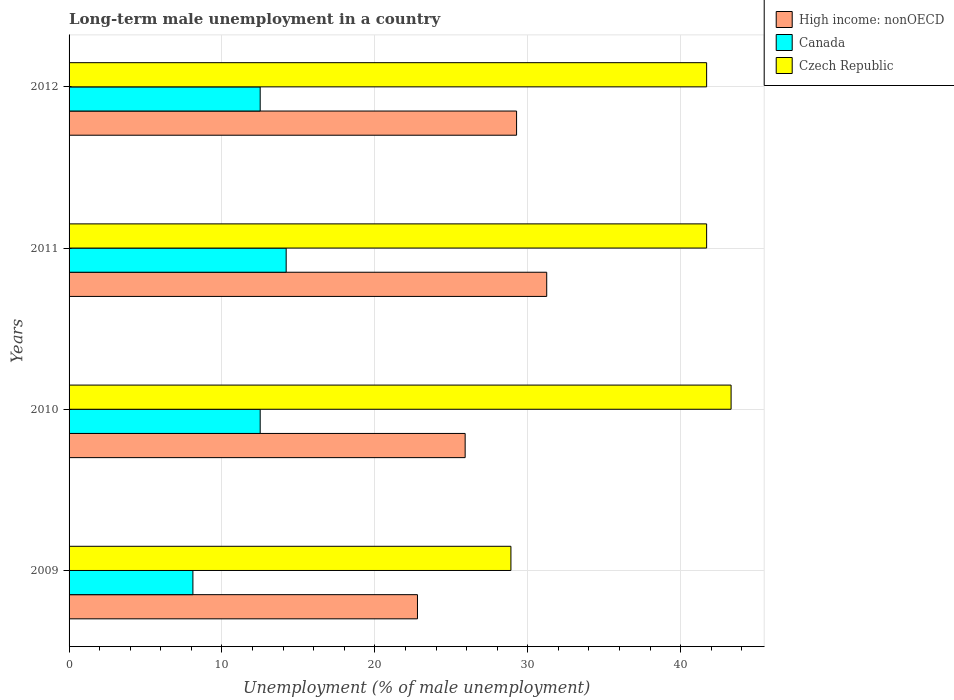How many different coloured bars are there?
Your answer should be very brief. 3. How many groups of bars are there?
Offer a terse response. 4. Are the number of bars on each tick of the Y-axis equal?
Your answer should be compact. Yes. How many bars are there on the 2nd tick from the top?
Your answer should be compact. 3. How many bars are there on the 1st tick from the bottom?
Give a very brief answer. 3. What is the label of the 3rd group of bars from the top?
Keep it short and to the point. 2010. What is the percentage of long-term unemployed male population in Czech Republic in 2009?
Your answer should be compact. 28.9. Across all years, what is the maximum percentage of long-term unemployed male population in High income: nonOECD?
Provide a short and direct response. 31.24. Across all years, what is the minimum percentage of long-term unemployed male population in Czech Republic?
Keep it short and to the point. 28.9. In which year was the percentage of long-term unemployed male population in Czech Republic maximum?
Give a very brief answer. 2010. In which year was the percentage of long-term unemployed male population in High income: nonOECD minimum?
Give a very brief answer. 2009. What is the total percentage of long-term unemployed male population in Czech Republic in the graph?
Make the answer very short. 155.6. What is the difference between the percentage of long-term unemployed male population in Canada in 2010 and that in 2012?
Offer a terse response. 0. What is the difference between the percentage of long-term unemployed male population in Canada in 2009 and the percentage of long-term unemployed male population in Czech Republic in 2011?
Offer a very short reply. -33.6. What is the average percentage of long-term unemployed male population in High income: nonOECD per year?
Offer a terse response. 27.3. In the year 2011, what is the difference between the percentage of long-term unemployed male population in High income: nonOECD and percentage of long-term unemployed male population in Canada?
Ensure brevity in your answer.  17.04. What is the ratio of the percentage of long-term unemployed male population in Canada in 2009 to that in 2012?
Make the answer very short. 0.65. What is the difference between the highest and the second highest percentage of long-term unemployed male population in High income: nonOECD?
Your answer should be very brief. 1.97. What is the difference between the highest and the lowest percentage of long-term unemployed male population in Czech Republic?
Your answer should be compact. 14.4. In how many years, is the percentage of long-term unemployed male population in High income: nonOECD greater than the average percentage of long-term unemployed male population in High income: nonOECD taken over all years?
Keep it short and to the point. 2. What does the 1st bar from the top in 2009 represents?
Provide a succinct answer. Czech Republic. What does the 3rd bar from the bottom in 2012 represents?
Make the answer very short. Czech Republic. Are all the bars in the graph horizontal?
Ensure brevity in your answer.  Yes. How many years are there in the graph?
Provide a succinct answer. 4. Does the graph contain any zero values?
Your response must be concise. No. Does the graph contain grids?
Your response must be concise. Yes. What is the title of the graph?
Provide a short and direct response. Long-term male unemployment in a country. Does "Mozambique" appear as one of the legend labels in the graph?
Your answer should be very brief. No. What is the label or title of the X-axis?
Provide a short and direct response. Unemployment (% of male unemployment). What is the label or title of the Y-axis?
Your answer should be very brief. Years. What is the Unemployment (% of male unemployment) in High income: nonOECD in 2009?
Provide a succinct answer. 22.79. What is the Unemployment (% of male unemployment) of Canada in 2009?
Make the answer very short. 8.1. What is the Unemployment (% of male unemployment) in Czech Republic in 2009?
Make the answer very short. 28.9. What is the Unemployment (% of male unemployment) in High income: nonOECD in 2010?
Your answer should be very brief. 25.91. What is the Unemployment (% of male unemployment) of Canada in 2010?
Provide a short and direct response. 12.5. What is the Unemployment (% of male unemployment) of Czech Republic in 2010?
Ensure brevity in your answer.  43.3. What is the Unemployment (% of male unemployment) in High income: nonOECD in 2011?
Offer a terse response. 31.24. What is the Unemployment (% of male unemployment) in Canada in 2011?
Your response must be concise. 14.2. What is the Unemployment (% of male unemployment) in Czech Republic in 2011?
Provide a succinct answer. 41.7. What is the Unemployment (% of male unemployment) in High income: nonOECD in 2012?
Give a very brief answer. 29.27. What is the Unemployment (% of male unemployment) of Canada in 2012?
Give a very brief answer. 12.5. What is the Unemployment (% of male unemployment) of Czech Republic in 2012?
Ensure brevity in your answer.  41.7. Across all years, what is the maximum Unemployment (% of male unemployment) of High income: nonOECD?
Ensure brevity in your answer.  31.24. Across all years, what is the maximum Unemployment (% of male unemployment) of Canada?
Provide a short and direct response. 14.2. Across all years, what is the maximum Unemployment (% of male unemployment) in Czech Republic?
Keep it short and to the point. 43.3. Across all years, what is the minimum Unemployment (% of male unemployment) of High income: nonOECD?
Your answer should be very brief. 22.79. Across all years, what is the minimum Unemployment (% of male unemployment) of Canada?
Your response must be concise. 8.1. Across all years, what is the minimum Unemployment (% of male unemployment) in Czech Republic?
Your response must be concise. 28.9. What is the total Unemployment (% of male unemployment) in High income: nonOECD in the graph?
Provide a short and direct response. 109.2. What is the total Unemployment (% of male unemployment) in Canada in the graph?
Your answer should be very brief. 47.3. What is the total Unemployment (% of male unemployment) of Czech Republic in the graph?
Provide a short and direct response. 155.6. What is the difference between the Unemployment (% of male unemployment) in High income: nonOECD in 2009 and that in 2010?
Provide a succinct answer. -3.12. What is the difference between the Unemployment (% of male unemployment) of Canada in 2009 and that in 2010?
Your response must be concise. -4.4. What is the difference between the Unemployment (% of male unemployment) of Czech Republic in 2009 and that in 2010?
Your answer should be very brief. -14.4. What is the difference between the Unemployment (% of male unemployment) in High income: nonOECD in 2009 and that in 2011?
Your response must be concise. -8.45. What is the difference between the Unemployment (% of male unemployment) of Canada in 2009 and that in 2011?
Keep it short and to the point. -6.1. What is the difference between the Unemployment (% of male unemployment) of Czech Republic in 2009 and that in 2011?
Keep it short and to the point. -12.8. What is the difference between the Unemployment (% of male unemployment) in High income: nonOECD in 2009 and that in 2012?
Provide a short and direct response. -6.48. What is the difference between the Unemployment (% of male unemployment) of Canada in 2009 and that in 2012?
Ensure brevity in your answer.  -4.4. What is the difference between the Unemployment (% of male unemployment) of High income: nonOECD in 2010 and that in 2011?
Keep it short and to the point. -5.34. What is the difference between the Unemployment (% of male unemployment) of Czech Republic in 2010 and that in 2011?
Offer a terse response. 1.6. What is the difference between the Unemployment (% of male unemployment) in High income: nonOECD in 2010 and that in 2012?
Keep it short and to the point. -3.36. What is the difference between the Unemployment (% of male unemployment) of Canada in 2010 and that in 2012?
Ensure brevity in your answer.  0. What is the difference between the Unemployment (% of male unemployment) in Czech Republic in 2010 and that in 2012?
Ensure brevity in your answer.  1.6. What is the difference between the Unemployment (% of male unemployment) in High income: nonOECD in 2011 and that in 2012?
Your answer should be very brief. 1.97. What is the difference between the Unemployment (% of male unemployment) of Canada in 2011 and that in 2012?
Your answer should be compact. 1.7. What is the difference between the Unemployment (% of male unemployment) in Czech Republic in 2011 and that in 2012?
Provide a short and direct response. 0. What is the difference between the Unemployment (% of male unemployment) in High income: nonOECD in 2009 and the Unemployment (% of male unemployment) in Canada in 2010?
Your answer should be compact. 10.29. What is the difference between the Unemployment (% of male unemployment) of High income: nonOECD in 2009 and the Unemployment (% of male unemployment) of Czech Republic in 2010?
Your response must be concise. -20.51. What is the difference between the Unemployment (% of male unemployment) in Canada in 2009 and the Unemployment (% of male unemployment) in Czech Republic in 2010?
Make the answer very short. -35.2. What is the difference between the Unemployment (% of male unemployment) of High income: nonOECD in 2009 and the Unemployment (% of male unemployment) of Canada in 2011?
Your answer should be compact. 8.59. What is the difference between the Unemployment (% of male unemployment) in High income: nonOECD in 2009 and the Unemployment (% of male unemployment) in Czech Republic in 2011?
Offer a terse response. -18.91. What is the difference between the Unemployment (% of male unemployment) of Canada in 2009 and the Unemployment (% of male unemployment) of Czech Republic in 2011?
Offer a very short reply. -33.6. What is the difference between the Unemployment (% of male unemployment) of High income: nonOECD in 2009 and the Unemployment (% of male unemployment) of Canada in 2012?
Your answer should be very brief. 10.29. What is the difference between the Unemployment (% of male unemployment) of High income: nonOECD in 2009 and the Unemployment (% of male unemployment) of Czech Republic in 2012?
Provide a succinct answer. -18.91. What is the difference between the Unemployment (% of male unemployment) in Canada in 2009 and the Unemployment (% of male unemployment) in Czech Republic in 2012?
Your response must be concise. -33.6. What is the difference between the Unemployment (% of male unemployment) of High income: nonOECD in 2010 and the Unemployment (% of male unemployment) of Canada in 2011?
Provide a succinct answer. 11.71. What is the difference between the Unemployment (% of male unemployment) in High income: nonOECD in 2010 and the Unemployment (% of male unemployment) in Czech Republic in 2011?
Give a very brief answer. -15.79. What is the difference between the Unemployment (% of male unemployment) in Canada in 2010 and the Unemployment (% of male unemployment) in Czech Republic in 2011?
Make the answer very short. -29.2. What is the difference between the Unemployment (% of male unemployment) in High income: nonOECD in 2010 and the Unemployment (% of male unemployment) in Canada in 2012?
Your answer should be very brief. 13.41. What is the difference between the Unemployment (% of male unemployment) of High income: nonOECD in 2010 and the Unemployment (% of male unemployment) of Czech Republic in 2012?
Make the answer very short. -15.79. What is the difference between the Unemployment (% of male unemployment) of Canada in 2010 and the Unemployment (% of male unemployment) of Czech Republic in 2012?
Ensure brevity in your answer.  -29.2. What is the difference between the Unemployment (% of male unemployment) of High income: nonOECD in 2011 and the Unemployment (% of male unemployment) of Canada in 2012?
Your response must be concise. 18.74. What is the difference between the Unemployment (% of male unemployment) of High income: nonOECD in 2011 and the Unemployment (% of male unemployment) of Czech Republic in 2012?
Your answer should be very brief. -10.46. What is the difference between the Unemployment (% of male unemployment) of Canada in 2011 and the Unemployment (% of male unemployment) of Czech Republic in 2012?
Provide a succinct answer. -27.5. What is the average Unemployment (% of male unemployment) of High income: nonOECD per year?
Offer a terse response. 27.3. What is the average Unemployment (% of male unemployment) in Canada per year?
Your answer should be very brief. 11.82. What is the average Unemployment (% of male unemployment) in Czech Republic per year?
Offer a very short reply. 38.9. In the year 2009, what is the difference between the Unemployment (% of male unemployment) of High income: nonOECD and Unemployment (% of male unemployment) of Canada?
Offer a terse response. 14.69. In the year 2009, what is the difference between the Unemployment (% of male unemployment) in High income: nonOECD and Unemployment (% of male unemployment) in Czech Republic?
Give a very brief answer. -6.11. In the year 2009, what is the difference between the Unemployment (% of male unemployment) of Canada and Unemployment (% of male unemployment) of Czech Republic?
Your answer should be compact. -20.8. In the year 2010, what is the difference between the Unemployment (% of male unemployment) of High income: nonOECD and Unemployment (% of male unemployment) of Canada?
Keep it short and to the point. 13.41. In the year 2010, what is the difference between the Unemployment (% of male unemployment) of High income: nonOECD and Unemployment (% of male unemployment) of Czech Republic?
Your answer should be very brief. -17.39. In the year 2010, what is the difference between the Unemployment (% of male unemployment) in Canada and Unemployment (% of male unemployment) in Czech Republic?
Provide a succinct answer. -30.8. In the year 2011, what is the difference between the Unemployment (% of male unemployment) in High income: nonOECD and Unemployment (% of male unemployment) in Canada?
Provide a short and direct response. 17.04. In the year 2011, what is the difference between the Unemployment (% of male unemployment) in High income: nonOECD and Unemployment (% of male unemployment) in Czech Republic?
Provide a succinct answer. -10.46. In the year 2011, what is the difference between the Unemployment (% of male unemployment) of Canada and Unemployment (% of male unemployment) of Czech Republic?
Offer a terse response. -27.5. In the year 2012, what is the difference between the Unemployment (% of male unemployment) of High income: nonOECD and Unemployment (% of male unemployment) of Canada?
Keep it short and to the point. 16.77. In the year 2012, what is the difference between the Unemployment (% of male unemployment) in High income: nonOECD and Unemployment (% of male unemployment) in Czech Republic?
Your response must be concise. -12.43. In the year 2012, what is the difference between the Unemployment (% of male unemployment) in Canada and Unemployment (% of male unemployment) in Czech Republic?
Provide a short and direct response. -29.2. What is the ratio of the Unemployment (% of male unemployment) in High income: nonOECD in 2009 to that in 2010?
Give a very brief answer. 0.88. What is the ratio of the Unemployment (% of male unemployment) of Canada in 2009 to that in 2010?
Provide a succinct answer. 0.65. What is the ratio of the Unemployment (% of male unemployment) in Czech Republic in 2009 to that in 2010?
Make the answer very short. 0.67. What is the ratio of the Unemployment (% of male unemployment) in High income: nonOECD in 2009 to that in 2011?
Offer a very short reply. 0.73. What is the ratio of the Unemployment (% of male unemployment) in Canada in 2009 to that in 2011?
Offer a terse response. 0.57. What is the ratio of the Unemployment (% of male unemployment) of Czech Republic in 2009 to that in 2011?
Your response must be concise. 0.69. What is the ratio of the Unemployment (% of male unemployment) in High income: nonOECD in 2009 to that in 2012?
Make the answer very short. 0.78. What is the ratio of the Unemployment (% of male unemployment) of Canada in 2009 to that in 2012?
Ensure brevity in your answer.  0.65. What is the ratio of the Unemployment (% of male unemployment) of Czech Republic in 2009 to that in 2012?
Offer a terse response. 0.69. What is the ratio of the Unemployment (% of male unemployment) in High income: nonOECD in 2010 to that in 2011?
Offer a very short reply. 0.83. What is the ratio of the Unemployment (% of male unemployment) in Canada in 2010 to that in 2011?
Your response must be concise. 0.88. What is the ratio of the Unemployment (% of male unemployment) of Czech Republic in 2010 to that in 2011?
Your answer should be compact. 1.04. What is the ratio of the Unemployment (% of male unemployment) in High income: nonOECD in 2010 to that in 2012?
Offer a terse response. 0.89. What is the ratio of the Unemployment (% of male unemployment) of Canada in 2010 to that in 2012?
Keep it short and to the point. 1. What is the ratio of the Unemployment (% of male unemployment) of Czech Republic in 2010 to that in 2012?
Offer a terse response. 1.04. What is the ratio of the Unemployment (% of male unemployment) of High income: nonOECD in 2011 to that in 2012?
Your response must be concise. 1.07. What is the ratio of the Unemployment (% of male unemployment) in Canada in 2011 to that in 2012?
Your response must be concise. 1.14. What is the ratio of the Unemployment (% of male unemployment) of Czech Republic in 2011 to that in 2012?
Make the answer very short. 1. What is the difference between the highest and the second highest Unemployment (% of male unemployment) in High income: nonOECD?
Your answer should be compact. 1.97. What is the difference between the highest and the lowest Unemployment (% of male unemployment) of High income: nonOECD?
Your response must be concise. 8.45. 